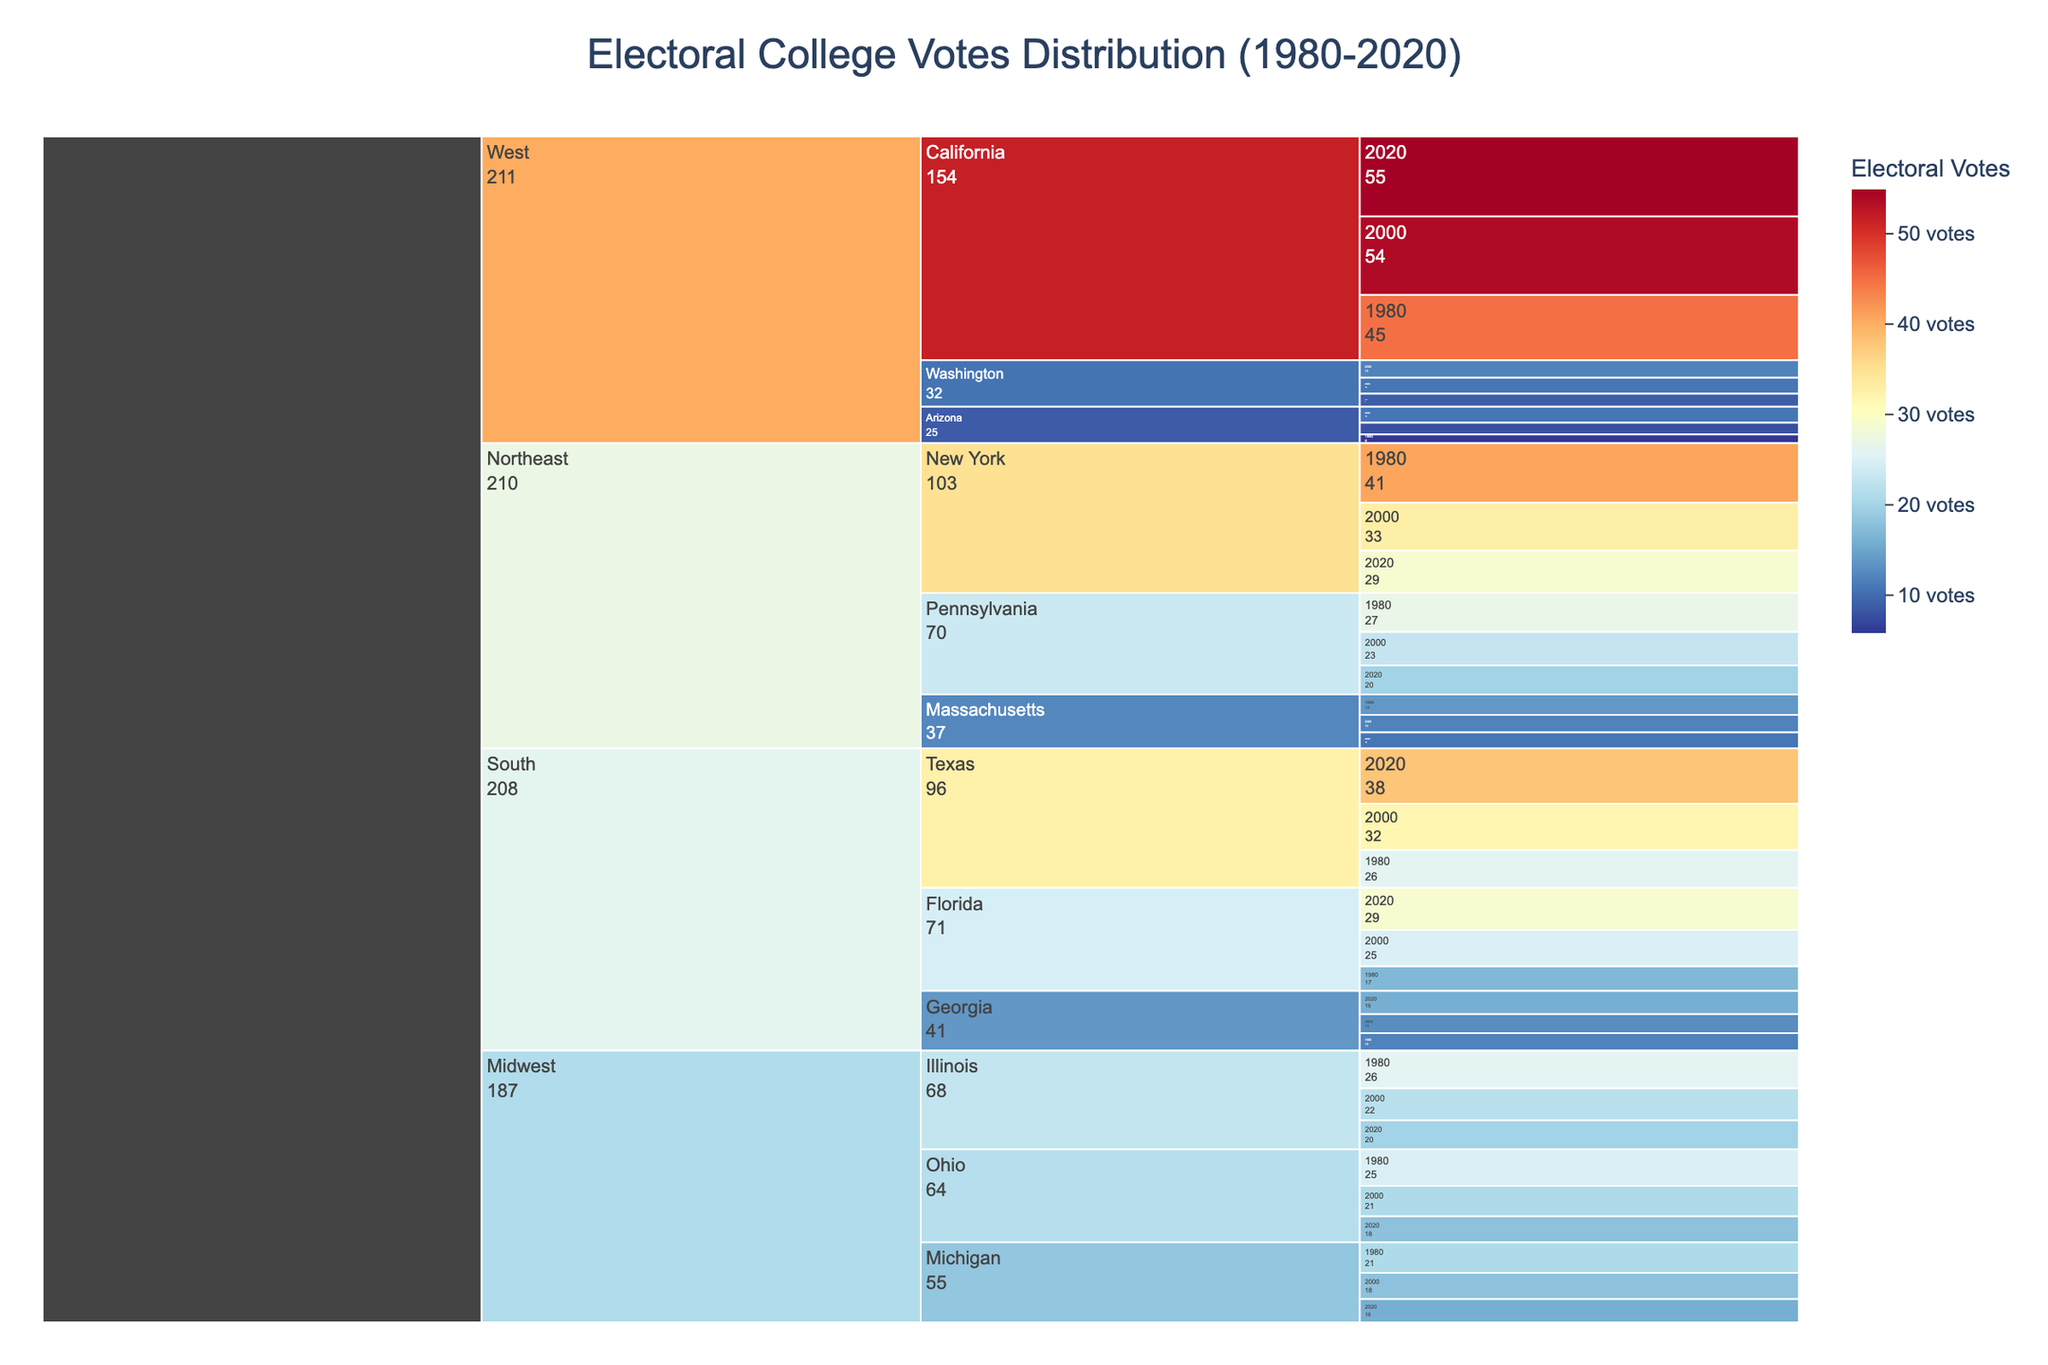What is the title of the icicle chart? The title of a plot is usually displayed at the top, centered. Reading it shows the chart’s purpose.
Answer: Electoral College Votes Distribution (1980-2020) Which state in the Northeast had the highest number of electoral votes in 1980? To answer this, locate the “Northeast” region, then compare the numbers for New York, Pennsylvania, and Massachusetts in 1980, noticing New York's highest value.
Answer: New York How many total electoral votes did Texas have in all three years combined? To find the total, locate Texas and sum the votes for 1980, 2000, and 2020. This is 26 + 32 + 38.
Answer: 96 Which region showed the highest increase in total electoral votes from 1980 to 2020? Calculate the sum of votes for each region in 1980 and 2020, then find the differences. The region with the highest positive difference is the answer.
Answer: South Which two states had an equal number of electoral votes in 2020? Compare the values for each state in the year 2020. Both Illinois and Pennsylvania have the same number of votes, 20.
Answer: Illinois and Pennsylvania What is the median number of electoral votes for the Northeast region in 2020? List the 2020 electoral votes for New York, Pennsylvania, and Massachusetts, which are 29, 20, and 11. Sort the list to find the middle value.
Answer: 20 Was there any state in the dataset where the number of electoral votes decreased consistently over all three depicted years? Go through each state's trend across the years and identify any with a consistent decrease, such as New York (41 to 33 to 29).
Answer: Yes, New York Which state in the West had the smallest increase in electoral votes from 1980 to 2020? Compare differences in votes from 1980 to 2020 for all West states. Washington had the smallest increase (9 to 12).
Answer: Washington 